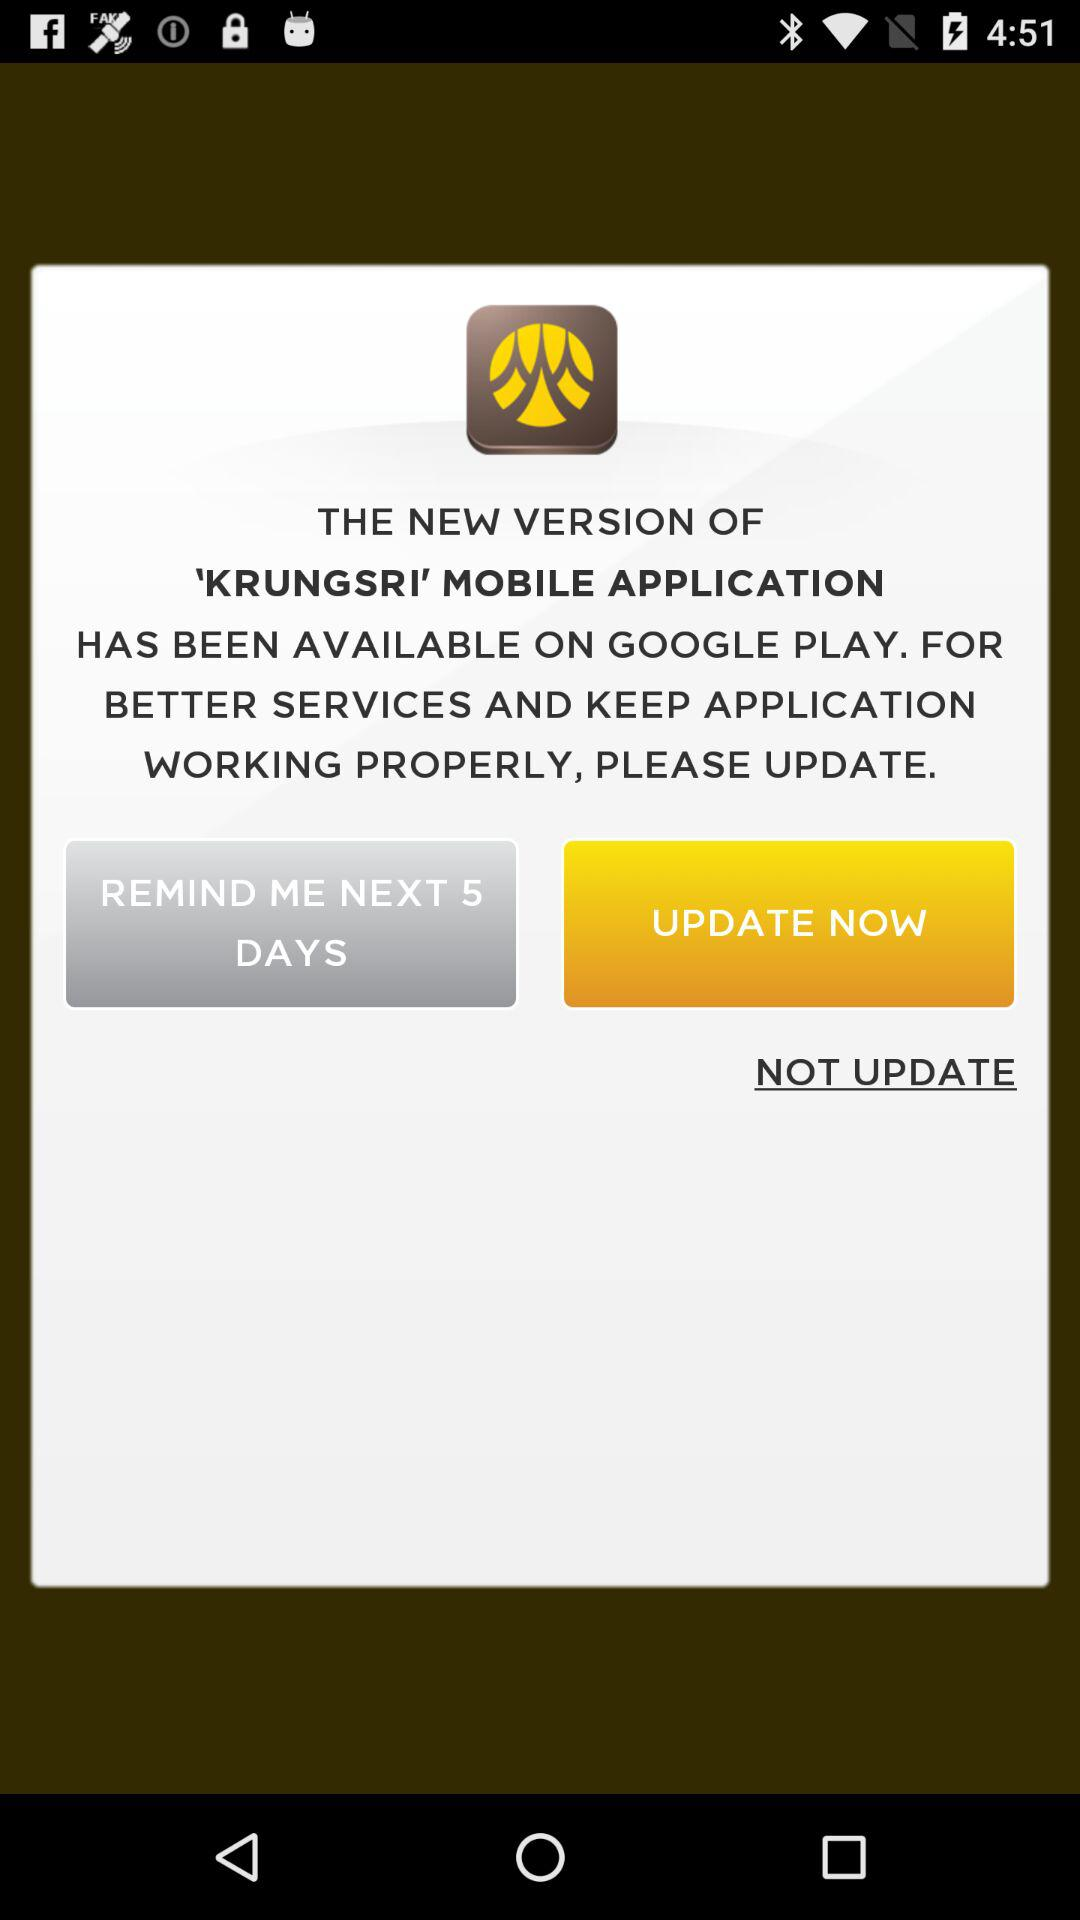What is the application name? The application name is "'KRUNGSRI' MOBILE APPLICATION". 